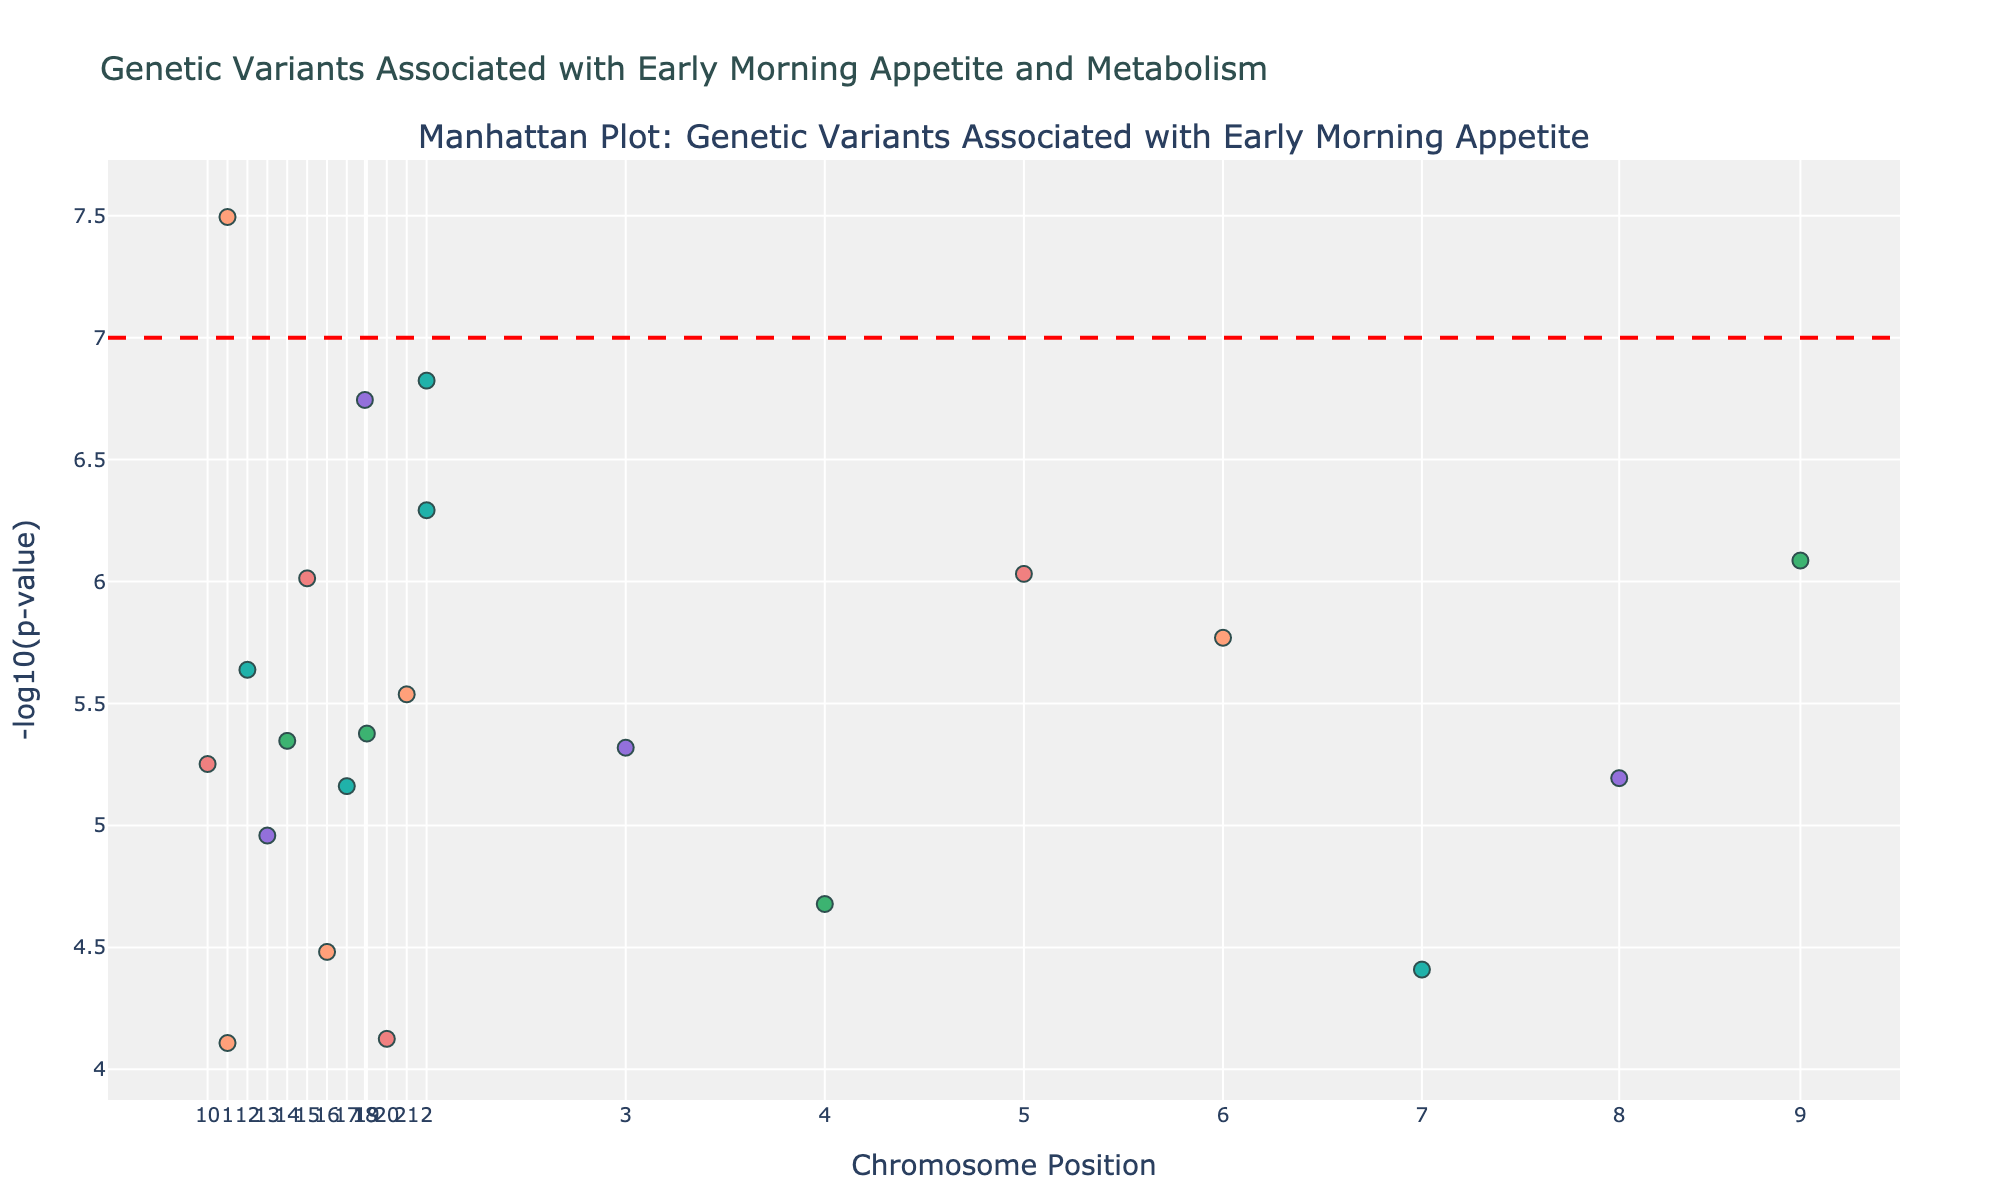What is the title of the plot? The title is displayed at the top of the plot and usually describes the main focus or data it represents. The plot title reads: ‘Genetic Variants Associated with Early Morning Appetite and Metabolism’.
Answer: Genetic Variants Associated with Early Morning Appetite and Metabolism Which chromosome has a significant variant based on p-values? Significance is often determined by a threshold, such as a p-value cutoff. In the plot, there's a red horizontal line marking this threshold. If markers of any chromosome cross this line, those variants are significant. Chromosome 1 intersects this threshold with the variant in gene PER1 (rs1234567).
Answer: Chromosome 1 Which chromosome shows the variant with the lowest p-value? The lower the p-value, the higher the value on the -log10(p-value) axis. By identifying the highest point on the y-axis, we can determine which chromosome it correlates with. Chromosome 1 has the highest point, indicating the lowest p-value variant.
Answer: Chromosome 1 How many variants are above the significance threshold? The significance threshold is marked by the horizontal red line. Count all the markers above this line. There are 3 markers (genes PER1, CLOCK, and CRY1).
Answer: 3 Which gene corresponds to the highest point on the plot? The highest point represents the lowest p-value in the dataset. By hovering over or checking the y-axis and corresponding labels, we see that the gene PER1 (rs1234567) on Chromosome 1 is the highest.
Answer: PER1 What's the p-value range represented in the plot? The plot shows p-values on a -log10(p-value) scale, ranging from the lowest markers up to the highest. The highest -log10(p-value) is 7, representing a p-value of 10^-7 (0.0000001), and the lowest -log10(p-value) markers indicate around -log10(0.000078) = 4.1.
Answer: 1e-07 to 7.8e-05 What is the -log10(p-value) of the variant in the LEP gene? Locate the LEP gene variant (rs1567890) on Chromosome 15 in the plot. Its y-axis value can be found directly from the plot. The calculated -log10(p-value) should be around 6.
Answer: 6 Which two genes have the closest p-values? Identify and compare the position of genes along the y-axis. Genes within a close range will have similar -log10(p-values). FTO (rs5678901) and MC4R (rs9012345) have almost the same position on the y-axis.
Answer: FTO and MC4R Which chromosome has the most variants in the plot? Count the number of marker points per chromosome. Chromosome 1, with 1 dense grouping, stands out as having the highest number of variants listed.
Answer: Chromosome 1 What's the significance threshold in terms of p-value? Find the value where the horizontal red line is set, which is commonly set at 5e-08 in genome-wide association studies. The corresponding y-value on the -log10(p-value) scale reveals the significance threshold.
Answer: 5e-08 